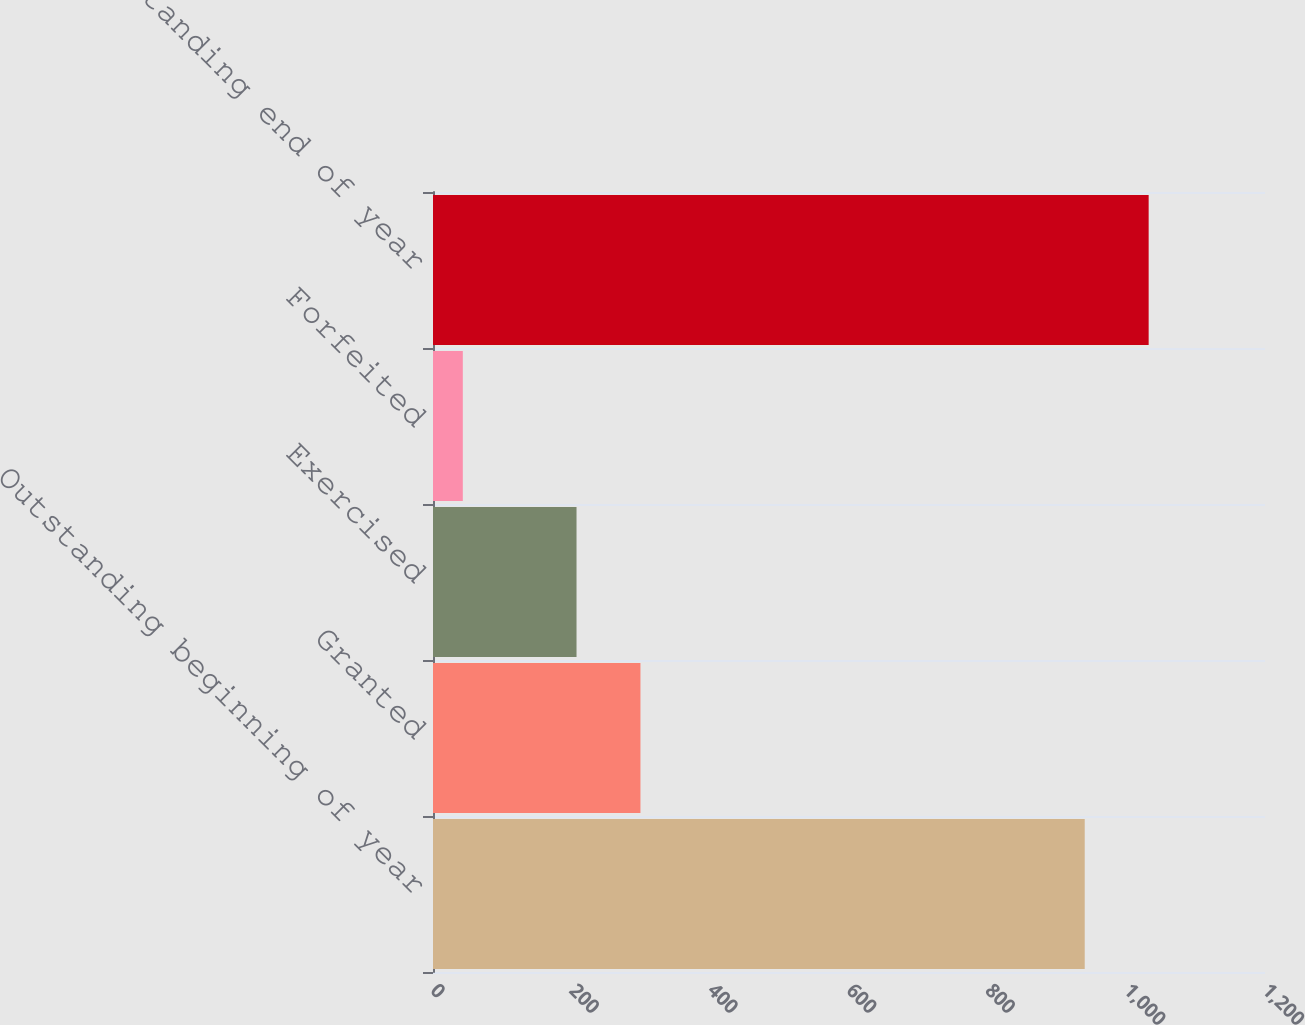Convert chart. <chart><loc_0><loc_0><loc_500><loc_500><bar_chart><fcel>Outstanding beginning of year<fcel>Granted<fcel>Exercised<fcel>Forfeited<fcel>Outstanding end of year<nl><fcel>940<fcel>299.2<fcel>207<fcel>43<fcel>1032.2<nl></chart> 